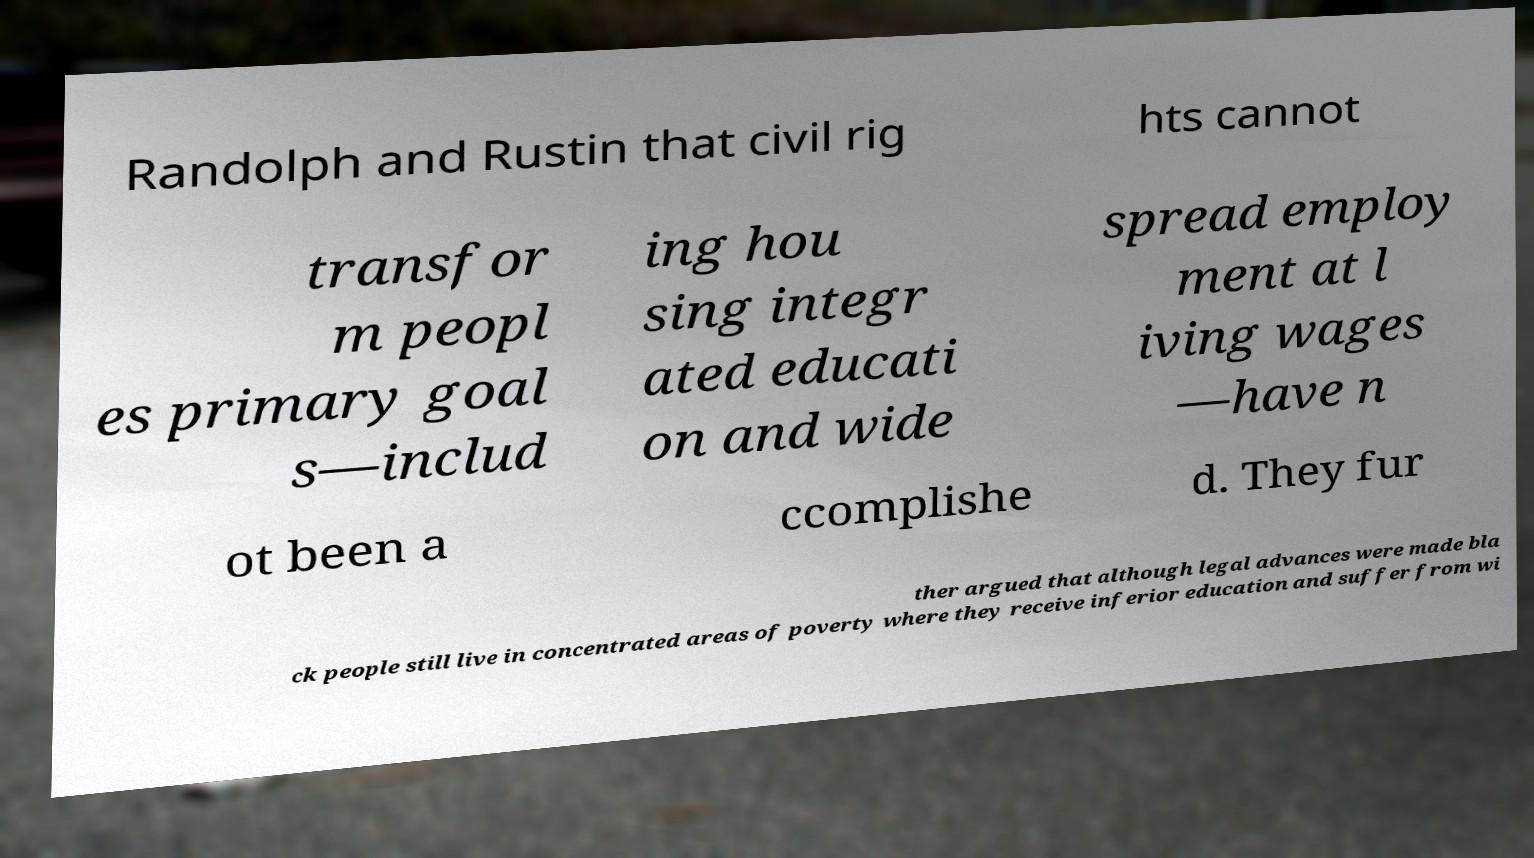There's text embedded in this image that I need extracted. Can you transcribe it verbatim? Randolph and Rustin that civil rig hts cannot transfor m peopl es primary goal s—includ ing hou sing integr ated educati on and wide spread employ ment at l iving wages —have n ot been a ccomplishe d. They fur ther argued that although legal advances were made bla ck people still live in concentrated areas of poverty where they receive inferior education and suffer from wi 